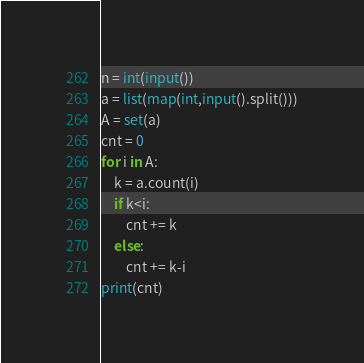Convert code to text. <code><loc_0><loc_0><loc_500><loc_500><_Python_>n = int(input())
a = list(map(int,input().split()))
A = set(a)
cnt = 0
for i in A:
    k = a.count(i)
    if k<i:
        cnt += k
    else:
        cnt += k-i
print(cnt)</code> 